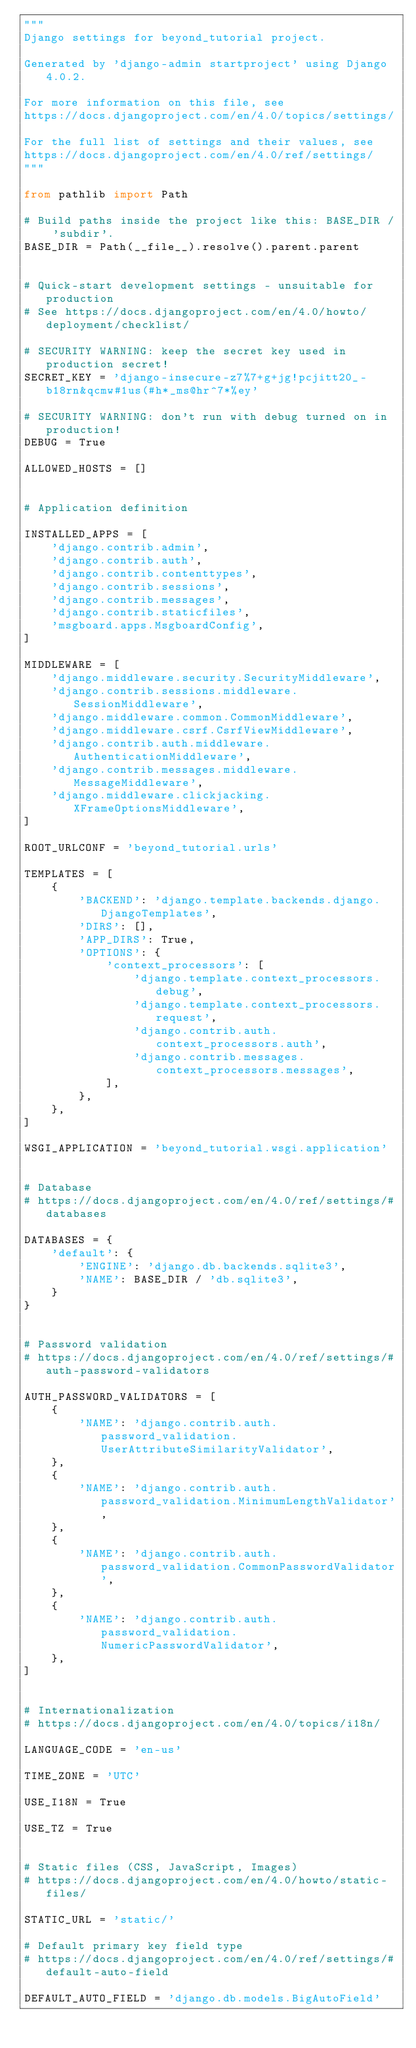Convert code to text. <code><loc_0><loc_0><loc_500><loc_500><_Python_>"""
Django settings for beyond_tutorial project.

Generated by 'django-admin startproject' using Django 4.0.2.

For more information on this file, see
https://docs.djangoproject.com/en/4.0/topics/settings/

For the full list of settings and their values, see
https://docs.djangoproject.com/en/4.0/ref/settings/
"""

from pathlib import Path

# Build paths inside the project like this: BASE_DIR / 'subdir'.
BASE_DIR = Path(__file__).resolve().parent.parent


# Quick-start development settings - unsuitable for production
# See https://docs.djangoproject.com/en/4.0/howto/deployment/checklist/

# SECURITY WARNING: keep the secret key used in production secret!
SECRET_KEY = 'django-insecure-z7%7+g+jg!pcjitt20_-b18rn&qcmw#1us(#h*_ms@hr^7*%ey'

# SECURITY WARNING: don't run with debug turned on in production!
DEBUG = True

ALLOWED_HOSTS = []


# Application definition

INSTALLED_APPS = [
    'django.contrib.admin',
    'django.contrib.auth',
    'django.contrib.contenttypes',
    'django.contrib.sessions',
    'django.contrib.messages',
    'django.contrib.staticfiles',
    'msgboard.apps.MsgboardConfig',
]

MIDDLEWARE = [
    'django.middleware.security.SecurityMiddleware',
    'django.contrib.sessions.middleware.SessionMiddleware',
    'django.middleware.common.CommonMiddleware',
    'django.middleware.csrf.CsrfViewMiddleware',
    'django.contrib.auth.middleware.AuthenticationMiddleware',
    'django.contrib.messages.middleware.MessageMiddleware',
    'django.middleware.clickjacking.XFrameOptionsMiddleware',
]

ROOT_URLCONF = 'beyond_tutorial.urls'

TEMPLATES = [
    {
        'BACKEND': 'django.template.backends.django.DjangoTemplates',
        'DIRS': [],
        'APP_DIRS': True,
        'OPTIONS': {
            'context_processors': [
                'django.template.context_processors.debug',
                'django.template.context_processors.request',
                'django.contrib.auth.context_processors.auth',
                'django.contrib.messages.context_processors.messages',
            ],
        },
    },
]

WSGI_APPLICATION = 'beyond_tutorial.wsgi.application'


# Database
# https://docs.djangoproject.com/en/4.0/ref/settings/#databases

DATABASES = {
    'default': {
        'ENGINE': 'django.db.backends.sqlite3',
        'NAME': BASE_DIR / 'db.sqlite3',
    }
}


# Password validation
# https://docs.djangoproject.com/en/4.0/ref/settings/#auth-password-validators

AUTH_PASSWORD_VALIDATORS = [
    {
        'NAME': 'django.contrib.auth.password_validation.UserAttributeSimilarityValidator',
    },
    {
        'NAME': 'django.contrib.auth.password_validation.MinimumLengthValidator',
    },
    {
        'NAME': 'django.contrib.auth.password_validation.CommonPasswordValidator',
    },
    {
        'NAME': 'django.contrib.auth.password_validation.NumericPasswordValidator',
    },
]


# Internationalization
# https://docs.djangoproject.com/en/4.0/topics/i18n/

LANGUAGE_CODE = 'en-us'

TIME_ZONE = 'UTC'

USE_I18N = True

USE_TZ = True


# Static files (CSS, JavaScript, Images)
# https://docs.djangoproject.com/en/4.0/howto/static-files/

STATIC_URL = 'static/'

# Default primary key field type
# https://docs.djangoproject.com/en/4.0/ref/settings/#default-auto-field

DEFAULT_AUTO_FIELD = 'django.db.models.BigAutoField'
</code> 